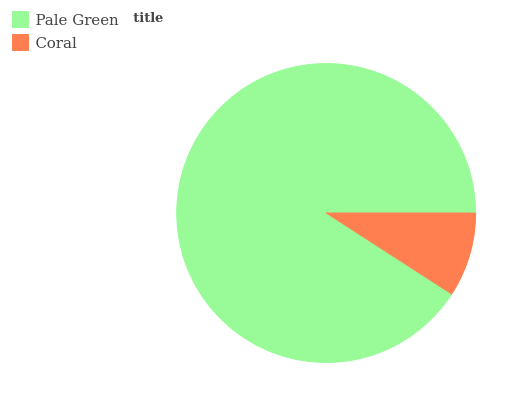Is Coral the minimum?
Answer yes or no. Yes. Is Pale Green the maximum?
Answer yes or no. Yes. Is Coral the maximum?
Answer yes or no. No. Is Pale Green greater than Coral?
Answer yes or no. Yes. Is Coral less than Pale Green?
Answer yes or no. Yes. Is Coral greater than Pale Green?
Answer yes or no. No. Is Pale Green less than Coral?
Answer yes or no. No. Is Pale Green the high median?
Answer yes or no. Yes. Is Coral the low median?
Answer yes or no. Yes. Is Coral the high median?
Answer yes or no. No. Is Pale Green the low median?
Answer yes or no. No. 